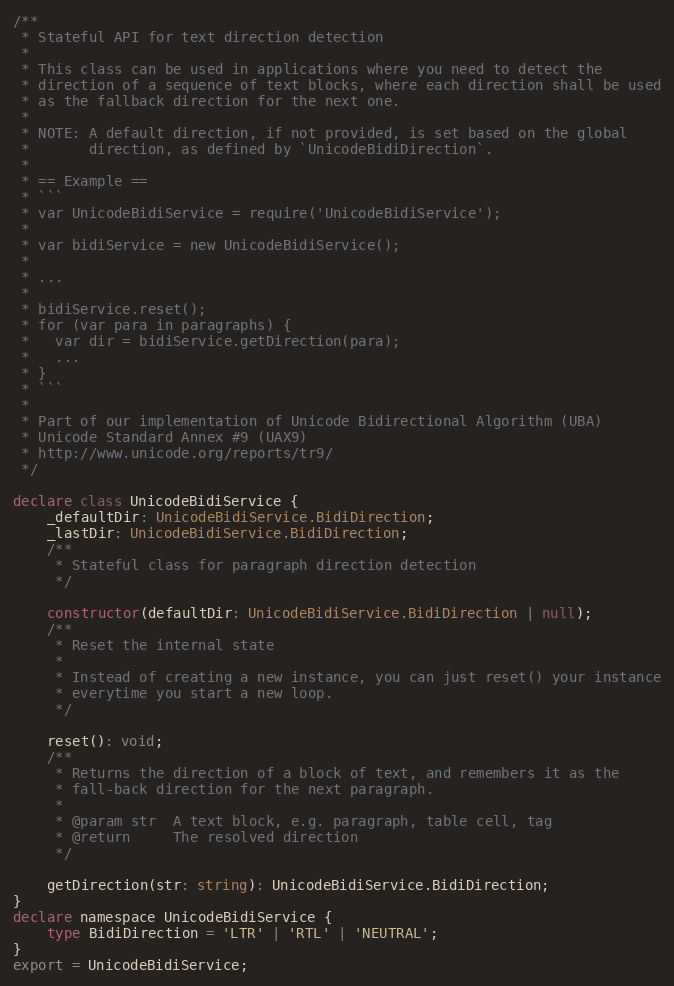Convert code to text. <code><loc_0><loc_0><loc_500><loc_500><_TypeScript_>/**
 * Stateful API for text direction detection
 *
 * This class can be used in applications where you need to detect the
 * direction of a sequence of text blocks, where each direction shall be used
 * as the fallback direction for the next one.
 *
 * NOTE: A default direction, if not provided, is set based on the global
 *       direction, as defined by `UnicodeBidiDirection`.
 *
 * == Example ==
 * ```
 * var UnicodeBidiService = require('UnicodeBidiService');
 *
 * var bidiService = new UnicodeBidiService();
 *
 * ...
 *
 * bidiService.reset();
 * for (var para in paragraphs) {
 *   var dir = bidiService.getDirection(para);
 *   ...
 * }
 * ```
 *
 * Part of our implementation of Unicode Bidirectional Algorithm (UBA)
 * Unicode Standard Annex #9 (UAX9)
 * http://www.unicode.org/reports/tr9/
 */

declare class UnicodeBidiService {
    _defaultDir: UnicodeBidiService.BidiDirection;
    _lastDir: UnicodeBidiService.BidiDirection;
    /**
     * Stateful class for paragraph direction detection
     */

    constructor(defaultDir: UnicodeBidiService.BidiDirection | null);
    /**
     * Reset the internal state
     *
     * Instead of creating a new instance, you can just reset() your instance
     * everytime you start a new loop.
     */

    reset(): void;
    /**
     * Returns the direction of a block of text, and remembers it as the
     * fall-back direction for the next paragraph.
     *
     * @param str  A text block, e.g. paragraph, table cell, tag
     * @return     The resolved direction
     */

    getDirection(str: string): UnicodeBidiService.BidiDirection;
}
declare namespace UnicodeBidiService {
    type BidiDirection = 'LTR' | 'RTL' | 'NEUTRAL';
}
export = UnicodeBidiService;
</code> 